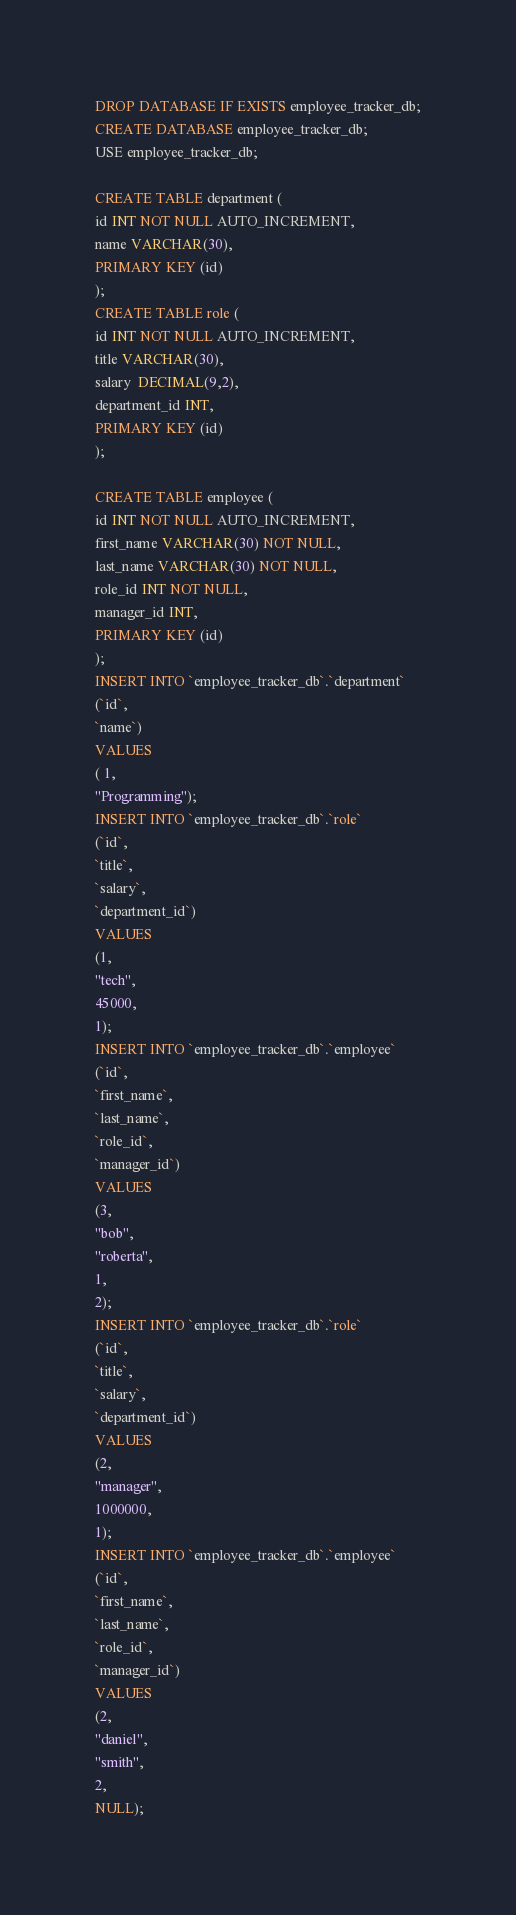Convert code to text. <code><loc_0><loc_0><loc_500><loc_500><_SQL_>
DROP DATABASE IF EXISTS employee_tracker_db;
CREATE DATABASE employee_tracker_db;
USE employee_tracker_db;

CREATE TABLE department (
id INT NOT NULL AUTO_INCREMENT,
name VARCHAR(30),
PRIMARY KEY (id)
);
CREATE TABLE role (
id INT NOT NULL AUTO_INCREMENT,
title VARCHAR(30), 
salary  DECIMAL(9,2),
department_id INT,
PRIMARY KEY (id)
);

CREATE TABLE employee (
id INT NOT NULL AUTO_INCREMENT,
first_name VARCHAR(30) NOT NULL,
last_name VARCHAR(30) NOT NULL,
role_id INT NOT NULL,
manager_id INT,
PRIMARY KEY (id)
);
INSERT INTO `employee_tracker_db`.`department`
(`id`,
`name`)
VALUES
( 1,
"Programming");
INSERT INTO `employee_tracker_db`.`role`
(`id`,
`title`,
`salary`,
`department_id`)
VALUES
(1,
"tech",
45000,
1);
INSERT INTO `employee_tracker_db`.`employee`
(`id`,
`first_name`,
`last_name`,
`role_id`,
`manager_id`)
VALUES
(3,
"bob",
"roberta",
1,
2);
INSERT INTO `employee_tracker_db`.`role`
(`id`,
`title`,
`salary`,
`department_id`)
VALUES
(2,
"manager",
1000000,
1);
INSERT INTO `employee_tracker_db`.`employee`
(`id`,
`first_name`,
`last_name`,
`role_id`,
`manager_id`)
VALUES
(2,
"daniel",
"smith",
2,
NULL);
















</code> 